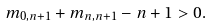Convert formula to latex. <formula><loc_0><loc_0><loc_500><loc_500>m _ { 0 , n + 1 } + m _ { n , n + 1 } - n + 1 > 0 .</formula> 